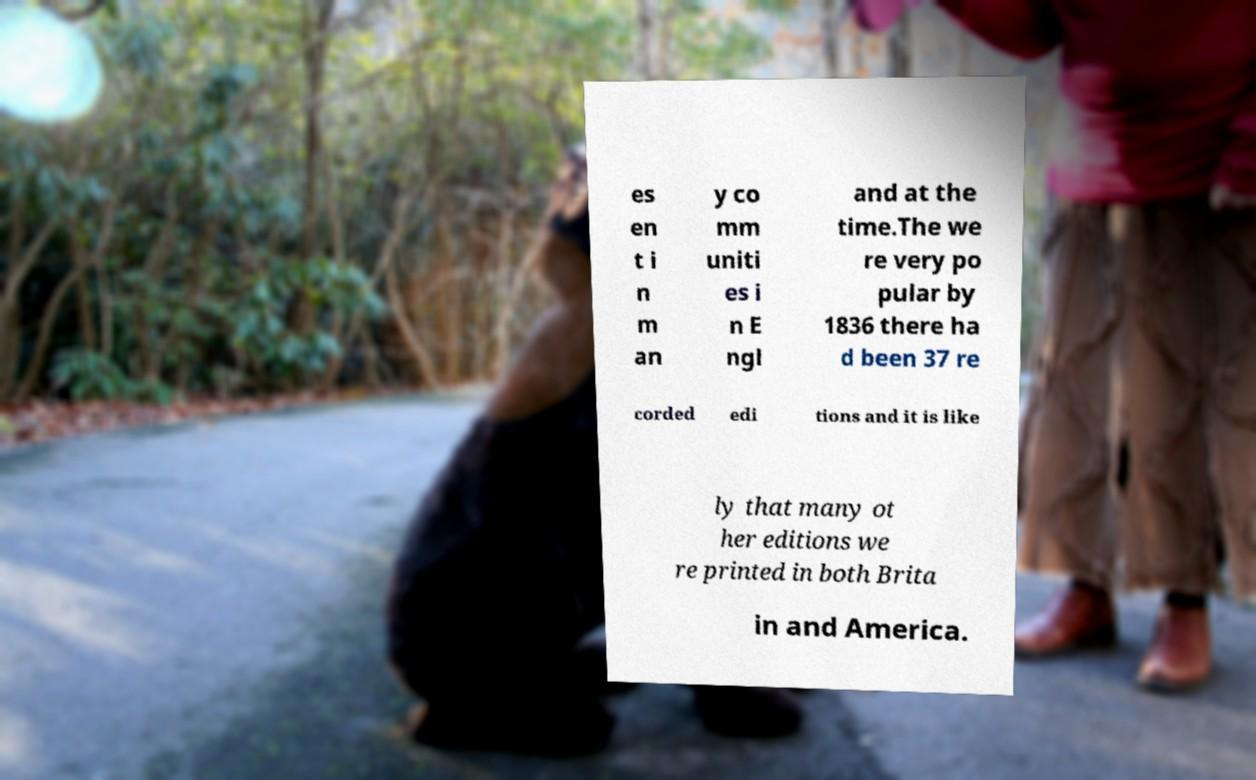Could you extract and type out the text from this image? es en t i n m an y co mm uniti es i n E ngl and at the time.The we re very po pular by 1836 there ha d been 37 re corded edi tions and it is like ly that many ot her editions we re printed in both Brita in and America. 